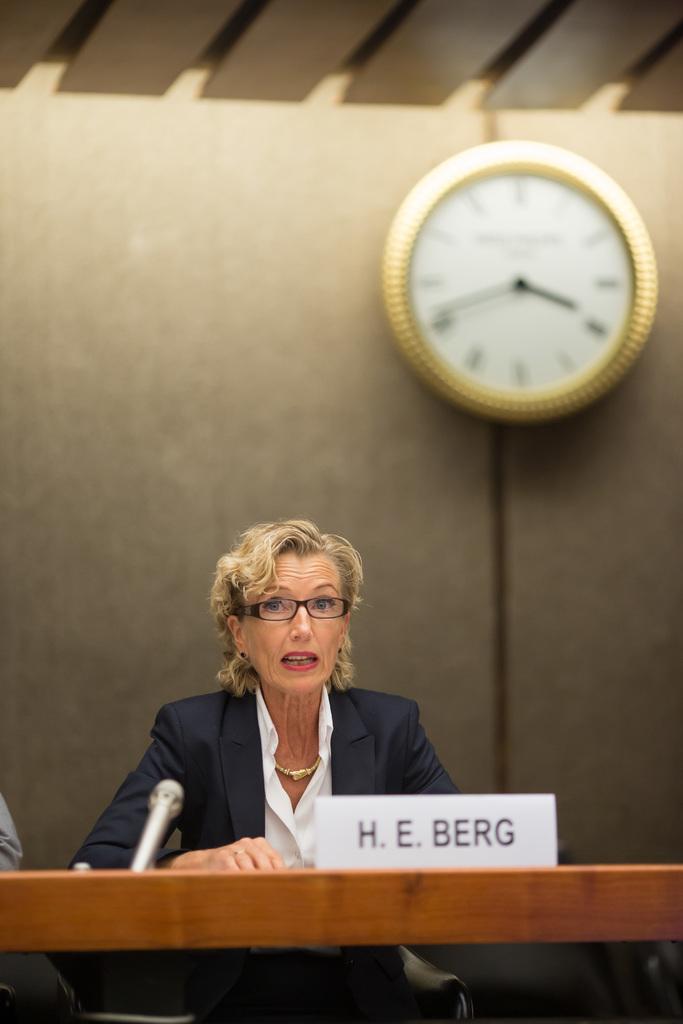What is her name?
Provide a succinct answer. H.e. berg. What is the time on the clock?
Give a very brief answer. 3:42. 